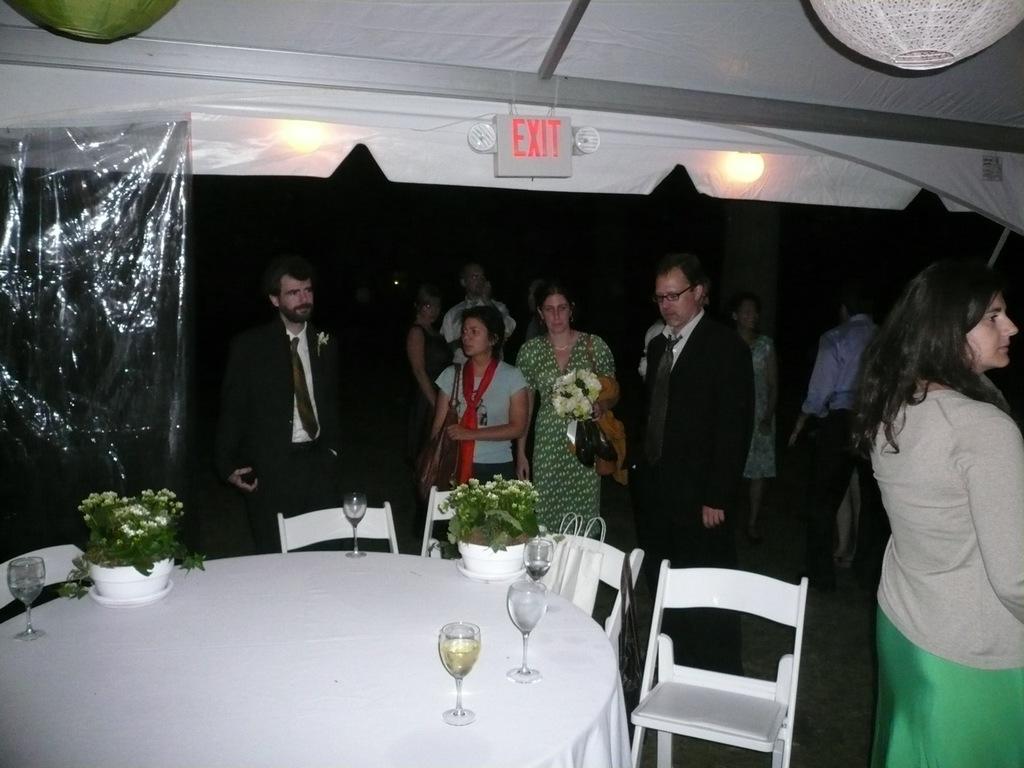Can you describe this image briefly? In this picture we can see some persons are standing on the floor. These are the chairs and there is a table. On the table there are glasses and these are the houseplants. Here we can see lights. 